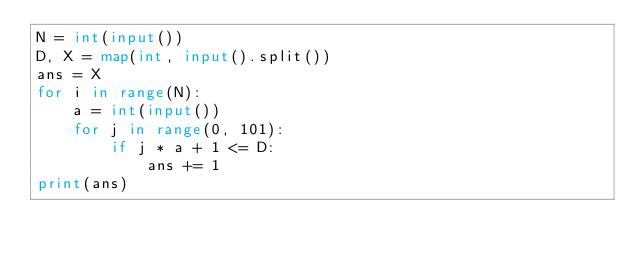<code> <loc_0><loc_0><loc_500><loc_500><_Python_>N = int(input())
D, X = map(int, input().split())
ans = X
for i in range(N):
    a = int(input())
    for j in range(0, 101):
        if j * a + 1 <= D:
            ans += 1
print(ans)
</code> 